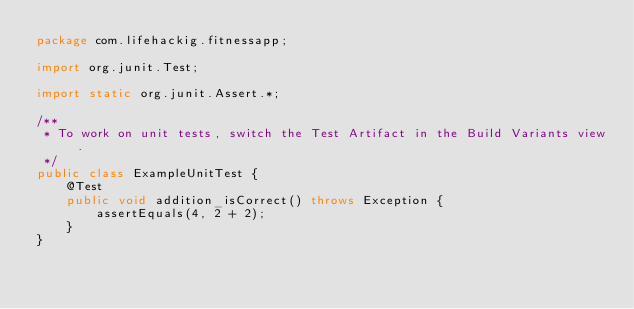Convert code to text. <code><loc_0><loc_0><loc_500><loc_500><_Java_>package com.lifehackig.fitnessapp;

import org.junit.Test;

import static org.junit.Assert.*;

/**
 * To work on unit tests, switch the Test Artifact in the Build Variants view.
 */
public class ExampleUnitTest {
    @Test
    public void addition_isCorrect() throws Exception {
        assertEquals(4, 2 + 2);
    }
}</code> 